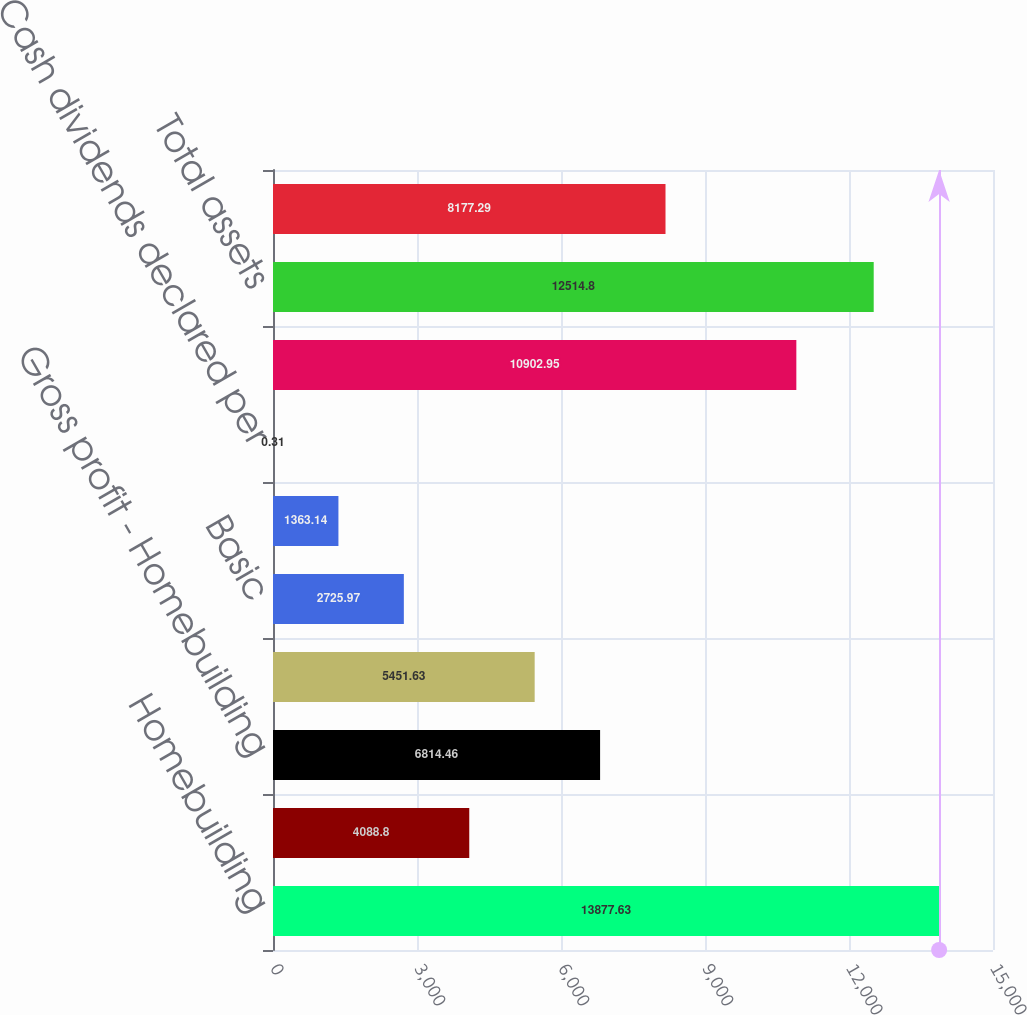<chart> <loc_0><loc_0><loc_500><loc_500><bar_chart><fcel>Homebuilding<fcel>Financial Services<fcel>Gross profit - Homebuilding<fcel>Net income<fcel>Basic<fcel>Diluted (3)<fcel>Cash dividends declared per<fcel>Inventories<fcel>Total assets<fcel>Notes payable<nl><fcel>13877.6<fcel>4088.8<fcel>6814.46<fcel>5451.63<fcel>2725.97<fcel>1363.14<fcel>0.31<fcel>10903<fcel>12514.8<fcel>8177.29<nl></chart> 